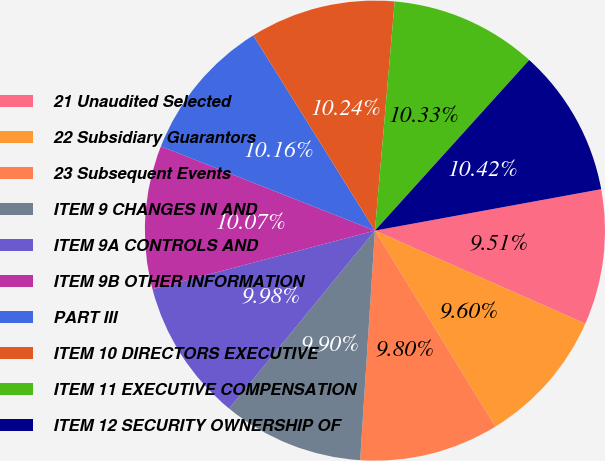Convert chart. <chart><loc_0><loc_0><loc_500><loc_500><pie_chart><fcel>21 Unaudited Selected<fcel>22 Subsidiary Guarantors<fcel>23 Subsequent Events<fcel>ITEM 9 CHANGES IN AND<fcel>ITEM 9A CONTROLS AND<fcel>ITEM 9B OTHER INFORMATION<fcel>PART III<fcel>ITEM 10 DIRECTORS EXECUTIVE<fcel>ITEM 11 EXECUTIVE COMPENSATION<fcel>ITEM 12 SECURITY OWNERSHIP OF<nl><fcel>9.51%<fcel>9.6%<fcel>9.8%<fcel>9.9%<fcel>9.98%<fcel>10.07%<fcel>10.16%<fcel>10.24%<fcel>10.33%<fcel>10.42%<nl></chart> 